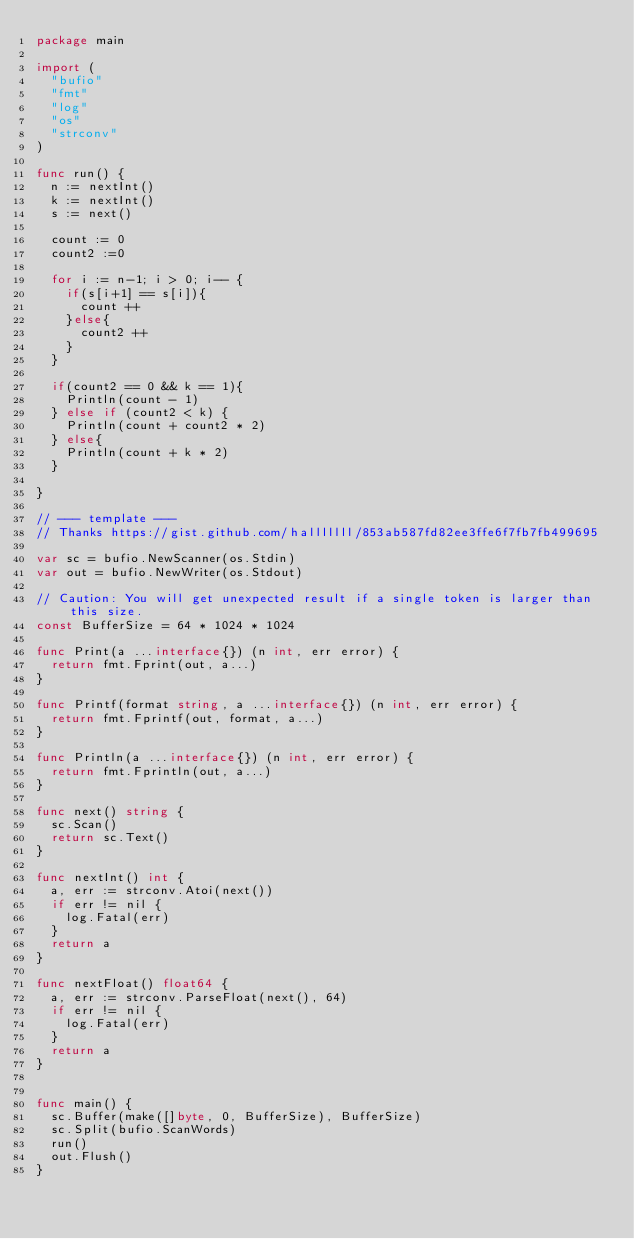<code> <loc_0><loc_0><loc_500><loc_500><_Go_>package main
 
import (
	"bufio"
	"fmt"
	"log"
	"os"
	"strconv"
)
 
func run() {
	n := nextInt()
	k := nextInt()
	s := next()
	
	count := 0
	count2 :=0
	
	for i := n-1; i > 0; i-- {
		if(s[i+1] == s[i]){ 
			count ++
		}else{
			count2 ++
		}	
	} 	
	
	if(count2 == 0 && k == 1){
		Println(count - 1)
	} else if (count2 < k) {
		Println(count + count2 * 2)
	} else{
		Println(count + k * 2)
	}
	
}

// --- template ---
// Thanks https://gist.github.com/halllllll/853ab587fd82ee3ffe6f7fb7fb499695
 
var sc = bufio.NewScanner(os.Stdin)
var out = bufio.NewWriter(os.Stdout)
 
// Caution: You will get unexpected result if a single token is larger than this size.
const BufferSize = 64 * 1024 * 1024
 
func Print(a ...interface{}) (n int, err error) {
	return fmt.Fprint(out, a...)
}
 
func Printf(format string, a ...interface{}) (n int, err error) {
	return fmt.Fprintf(out, format, a...)
}
 
func Println(a ...interface{}) (n int, err error) {
	return fmt.Fprintln(out, a...)
}
 
func next() string {
	sc.Scan()
	return sc.Text()
}
 
func nextInt() int {
	a, err := strconv.Atoi(next())
	if err != nil {
		log.Fatal(err)
	}
	return a
}
 
func nextFloat() float64 {
	a, err := strconv.ParseFloat(next(), 64)
	if err != nil {
		log.Fatal(err)
	}
	return a
}

 
func main() {
	sc.Buffer(make([]byte, 0, BufferSize), BufferSize)
	sc.Split(bufio.ScanWords)
	run()
	out.Flush()
}</code> 